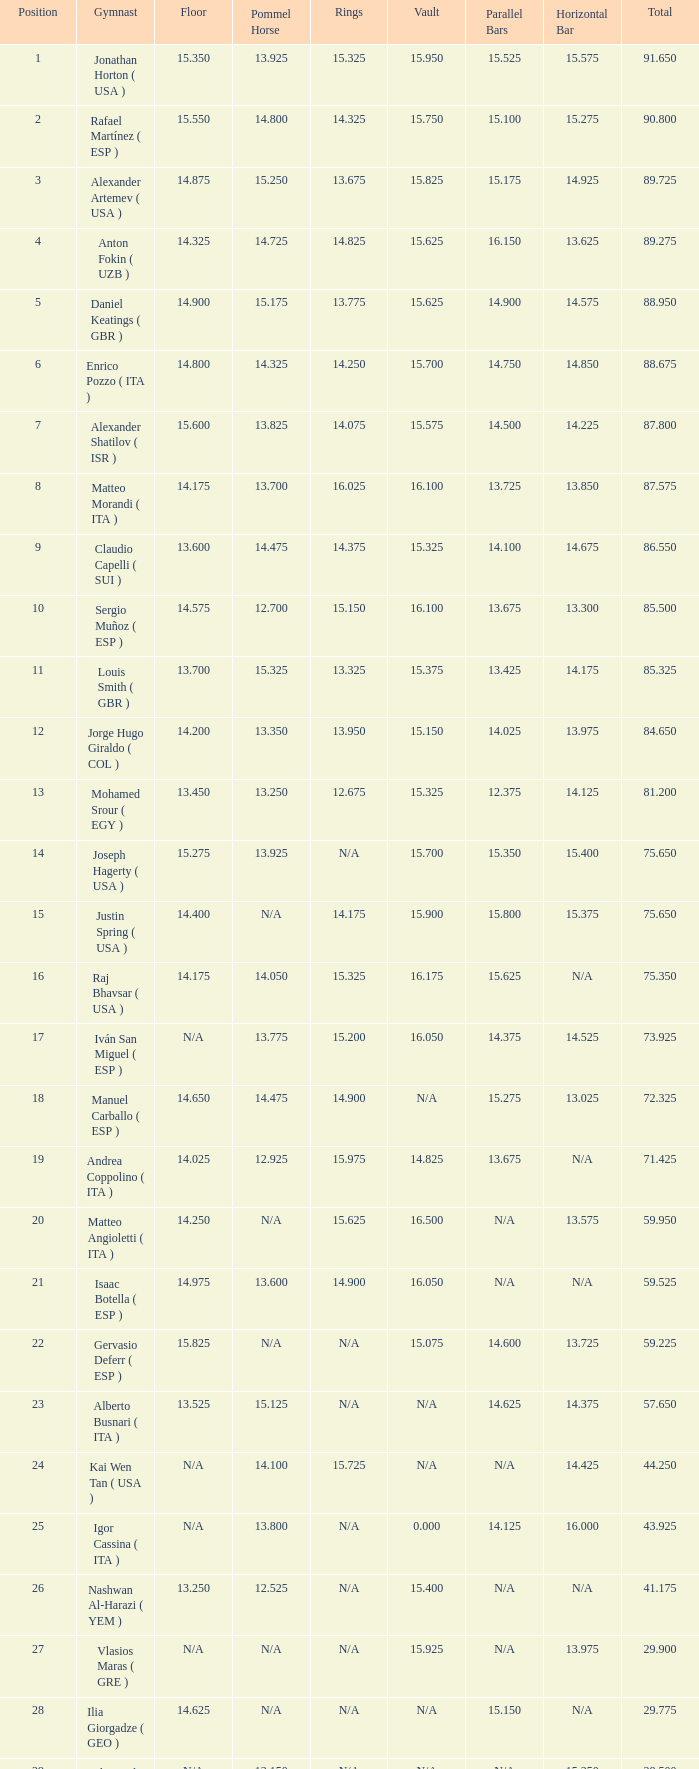If the parallel bars is 16.150, who is the gymnast? Anton Fokin ( UZB ). 